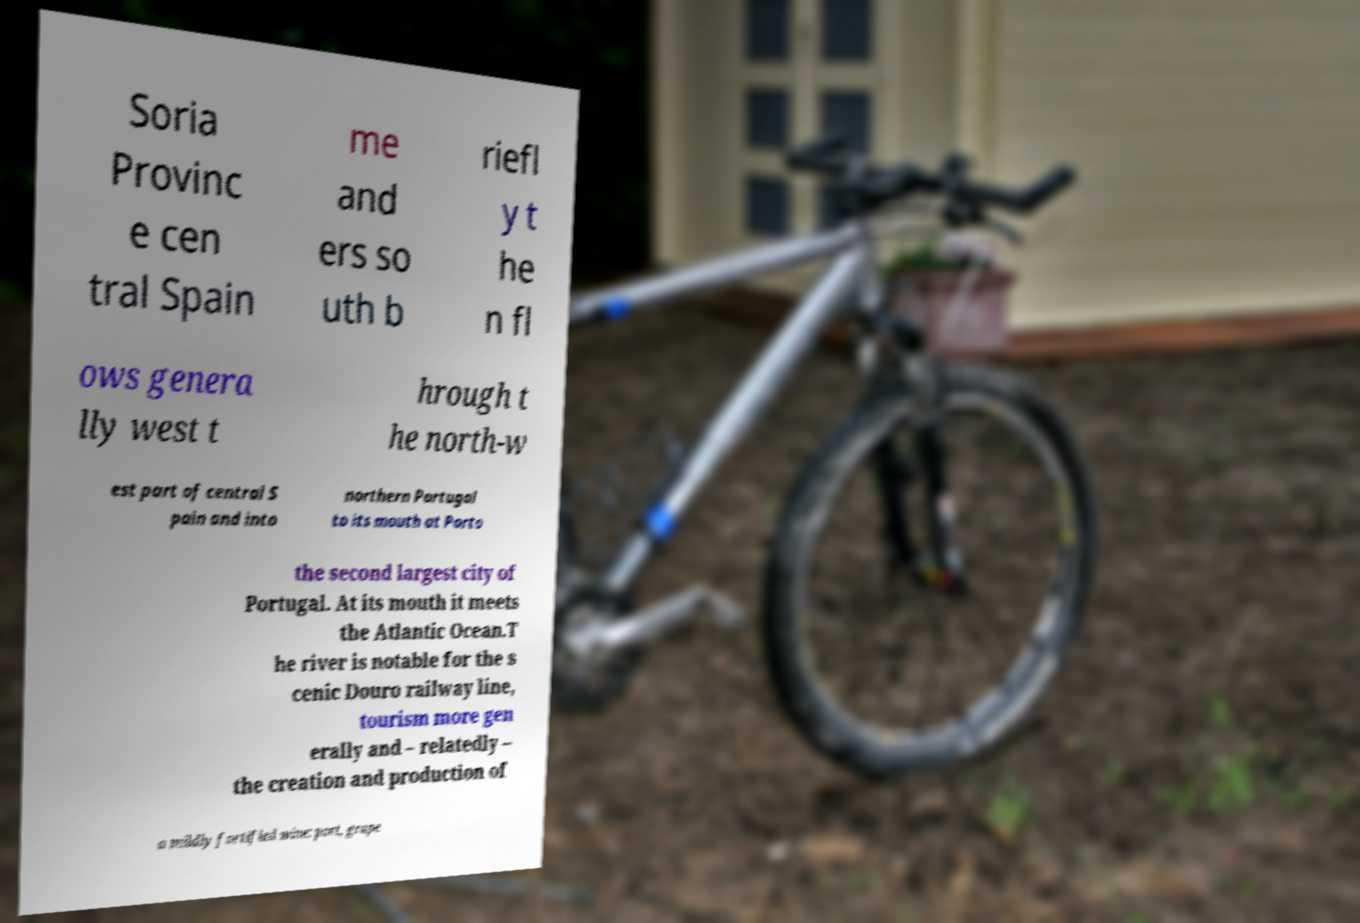Could you assist in decoding the text presented in this image and type it out clearly? Soria Provinc e cen tral Spain me and ers so uth b riefl y t he n fl ows genera lly west t hrough t he north-w est part of central S pain and into northern Portugal to its mouth at Porto the second largest city of Portugal. At its mouth it meets the Atlantic Ocean.T he river is notable for the s cenic Douro railway line, tourism more gen erally and – relatedly – the creation and production of a mildly fortified wine: port, grape 